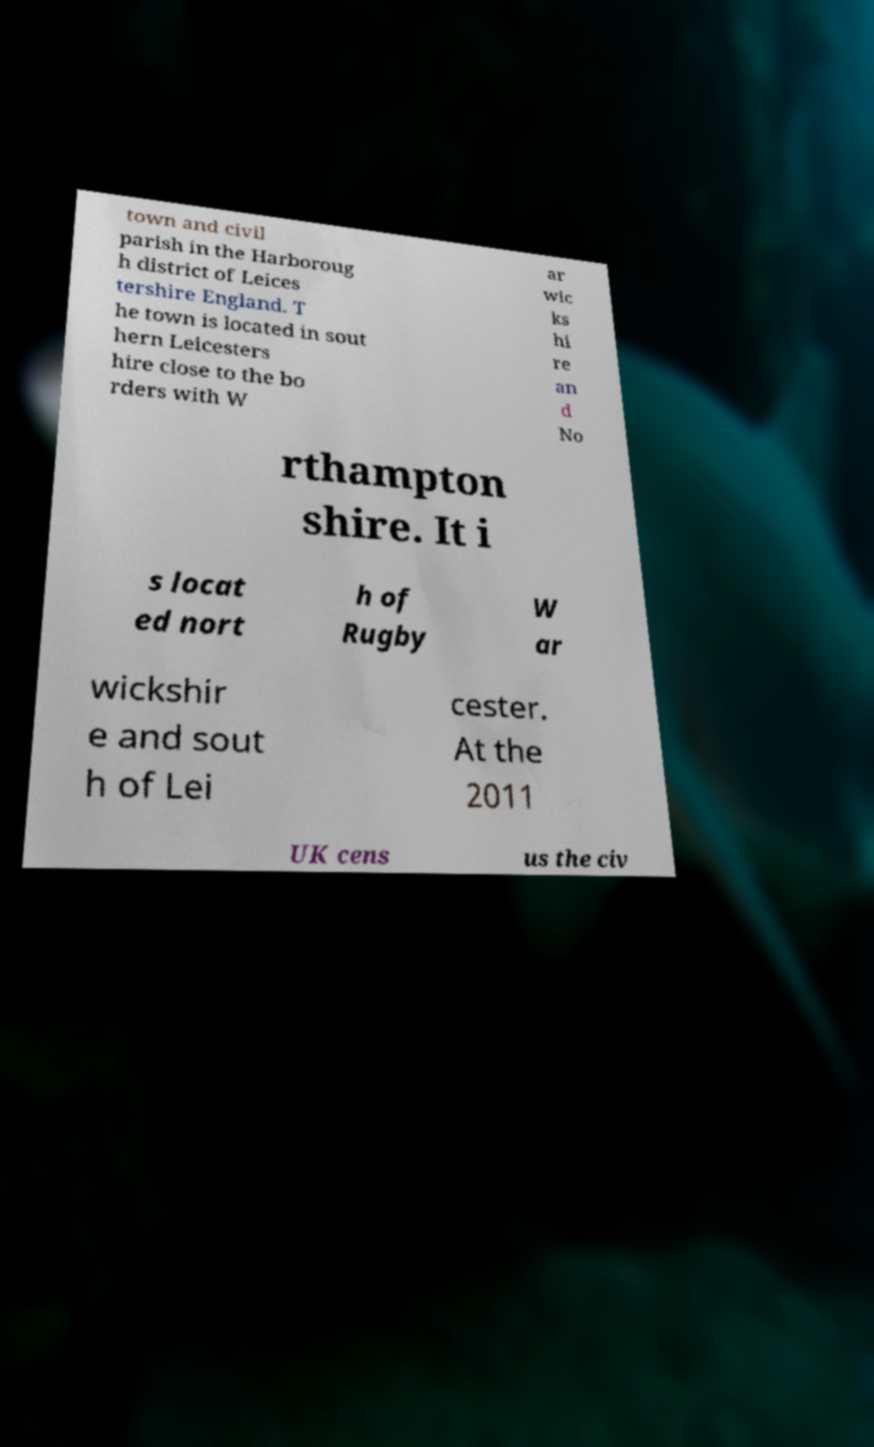I need the written content from this picture converted into text. Can you do that? town and civil parish in the Harboroug h district of Leices tershire England. T he town is located in sout hern Leicesters hire close to the bo rders with W ar wic ks hi re an d No rthampton shire. It i s locat ed nort h of Rugby W ar wickshir e and sout h of Lei cester. At the 2011 UK cens us the civ 